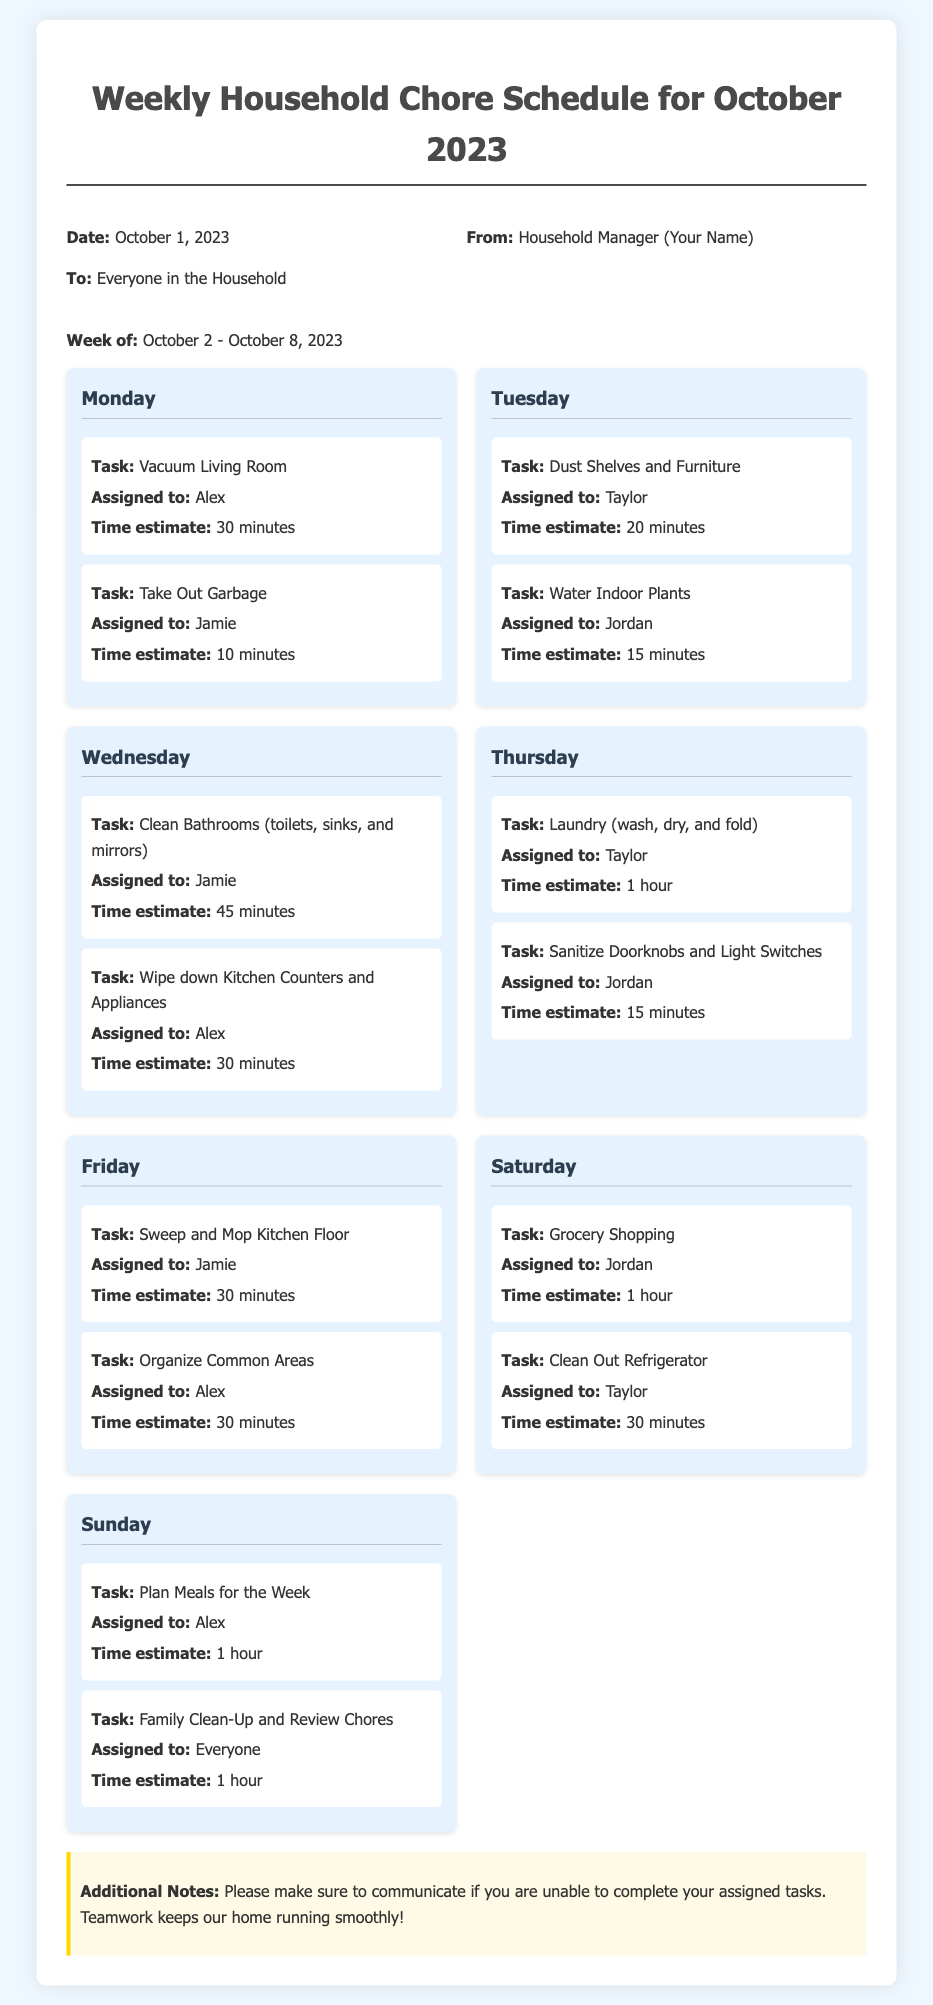what is the assigned task for Monday? The tasks for Monday include "Vacuum Living Room" and "Take Out Garbage".
Answer: Vacuum Living Room, Take Out Garbage who is responsible for cleaning bathrooms on Wednesday? The document specifies that Jamie is assigned to clean the bathrooms on Wednesday.
Answer: Jamie how much time is estimated for laundry on Thursday? The schedule indicates that the time estimate for laundry is 1 hour.
Answer: 1 hour which day includes grocery shopping? The assignment for grocery shopping is set for Saturday in the schedule.
Answer: Saturday how many tasks are assigned to Alex during the week? Alex has three tasks assigned: Vacuum Living Room, Wipe down Kitchen Counters and Appliances, and Plan Meals for the Week.
Answer: 3 what is the total time estimate for Family Clean-Up on Sunday? The total time estimate for the Family Clean-Up and Review Chores on Sunday is 1 hour.
Answer: 1 hour who is assigned the task of Dust Shelves and Furniture? The document states that the task of Dust Shelves and Furniture is assigned to Taylor on Tuesday.
Answer: Taylor what additional note is mentioned regarding teamwork? The note emphasizes the importance of communication if unable to complete tasks for smooth operation of the household.
Answer: Communication is important which task has the longest time estimate during the week? The longest time estimate is for Cleaning Bathrooms on Wednesday, which takes 45 minutes.
Answer: 45 minutes 